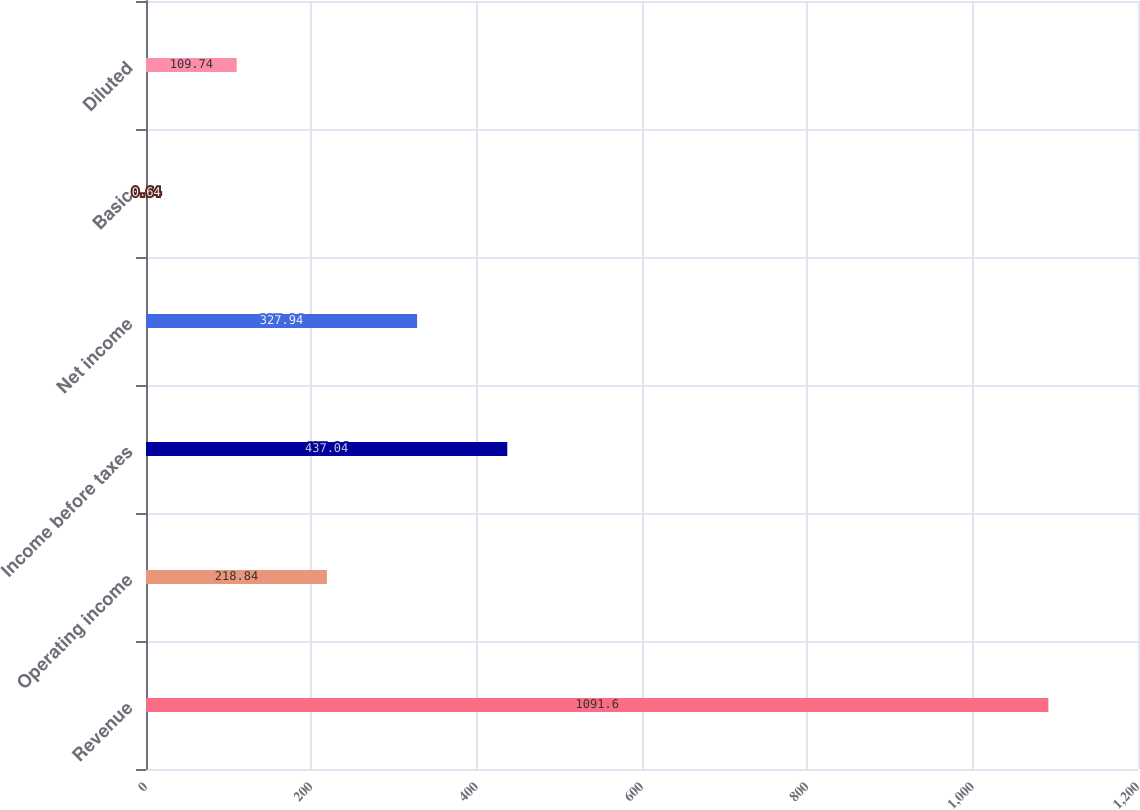Convert chart. <chart><loc_0><loc_0><loc_500><loc_500><bar_chart><fcel>Revenue<fcel>Operating income<fcel>Income before taxes<fcel>Net income<fcel>Basic<fcel>Diluted<nl><fcel>1091.6<fcel>218.84<fcel>437.04<fcel>327.94<fcel>0.64<fcel>109.74<nl></chart> 